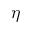Convert formula to latex. <formula><loc_0><loc_0><loc_500><loc_500>\eta</formula> 